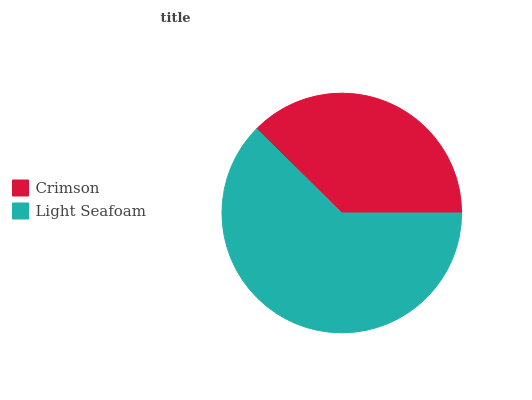Is Crimson the minimum?
Answer yes or no. Yes. Is Light Seafoam the maximum?
Answer yes or no. Yes. Is Light Seafoam the minimum?
Answer yes or no. No. Is Light Seafoam greater than Crimson?
Answer yes or no. Yes. Is Crimson less than Light Seafoam?
Answer yes or no. Yes. Is Crimson greater than Light Seafoam?
Answer yes or no. No. Is Light Seafoam less than Crimson?
Answer yes or no. No. Is Light Seafoam the high median?
Answer yes or no. Yes. Is Crimson the low median?
Answer yes or no. Yes. Is Crimson the high median?
Answer yes or no. No. Is Light Seafoam the low median?
Answer yes or no. No. 